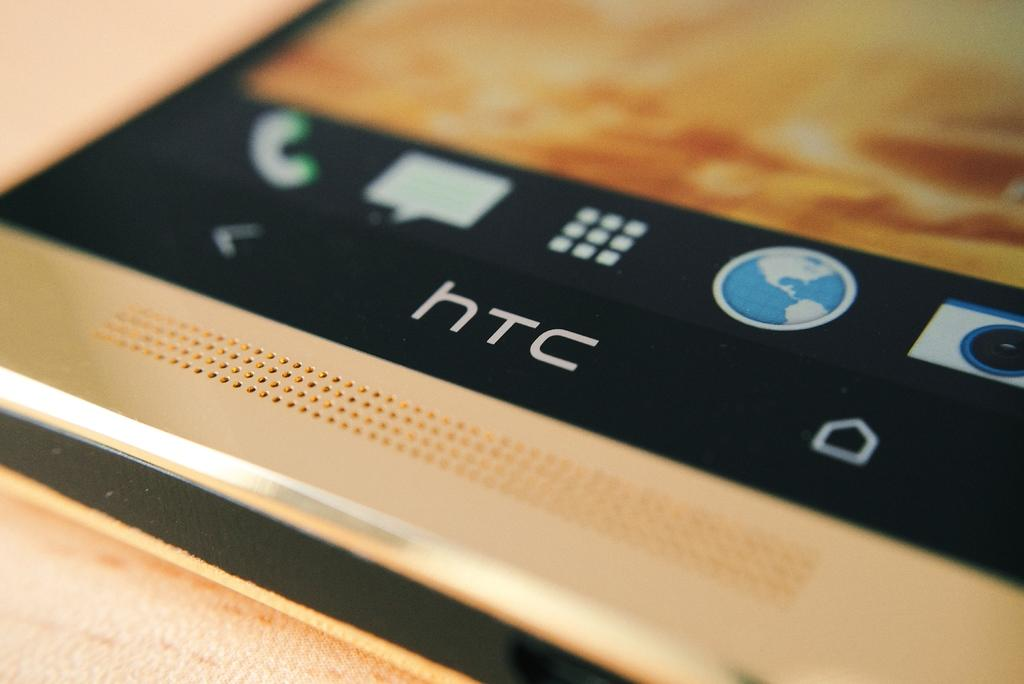What is the main object in the image? There is a mobile in the image. What can be seen on the mobile? There are icons visible on the mobile. What color is the surface on which the mobile is placed? The mobile is on a cream-colored surface. Can you describe the background of the image? The background of the image is blurred. What direction is the apple being pushed in the image? There is no apple present in the image, so it cannot be pushed in any direction. 